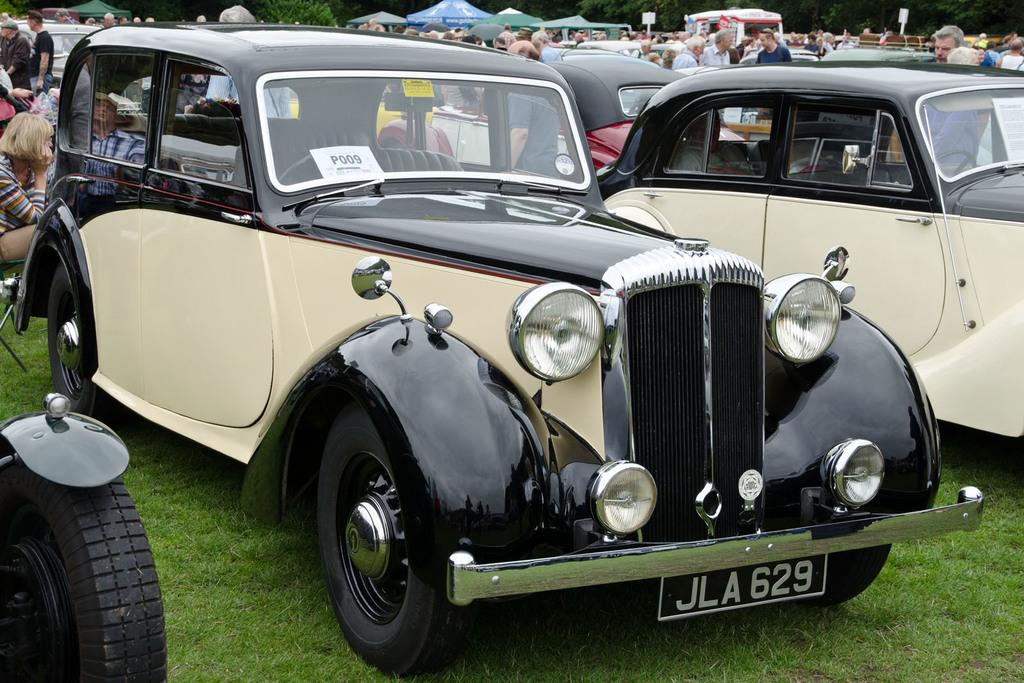What is the location of the vehicles in the image? The vehicles are parked on the grass in the image. What are the people doing in the image? The people are in the middle of the vehicles. What type of setting is depicted in the image? There are camps in the image, suggesting an outdoor or recreational area. What can be seen in the background of the image? There are trees in the image. What type of engine can be seen powering the net in the image? There is no engine or net present in the image. What type of legal advice is being given to the people in the image? There is no lawyer or legal advice present in the image. 